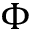<formula> <loc_0><loc_0><loc_500><loc_500>\Phi</formula> 